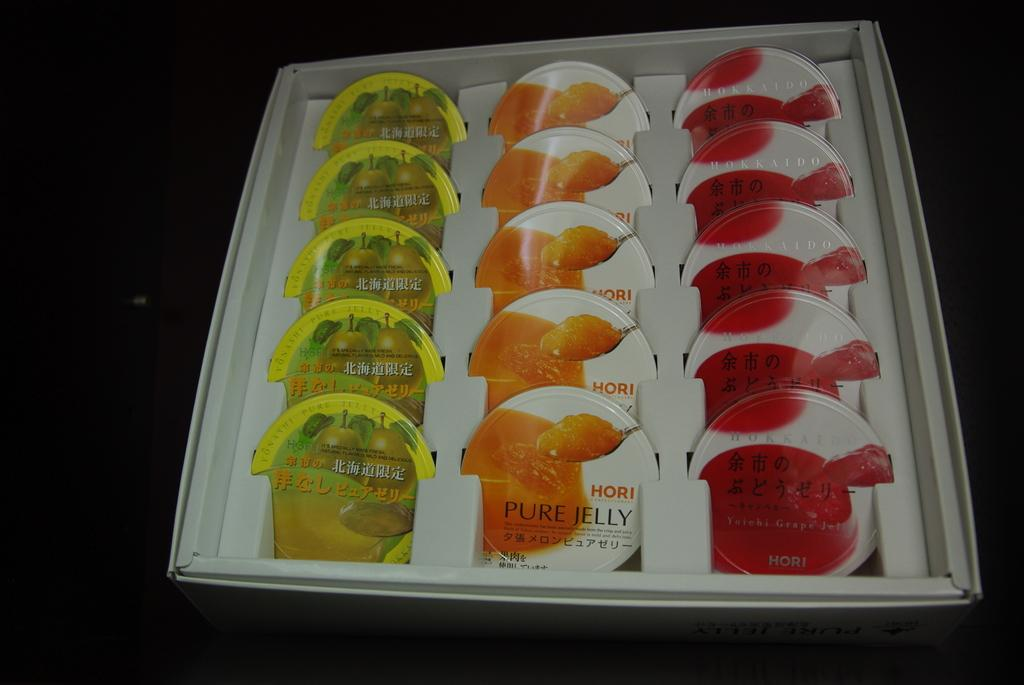What is the main object in the image? There is a tray in the image. What is placed on the tray? There are boxes arranged on the tray. What type of feeling can be seen on the seashore in the image? There is no seashore or feeling present in the image; it only features a tray with boxes arranged on it. 